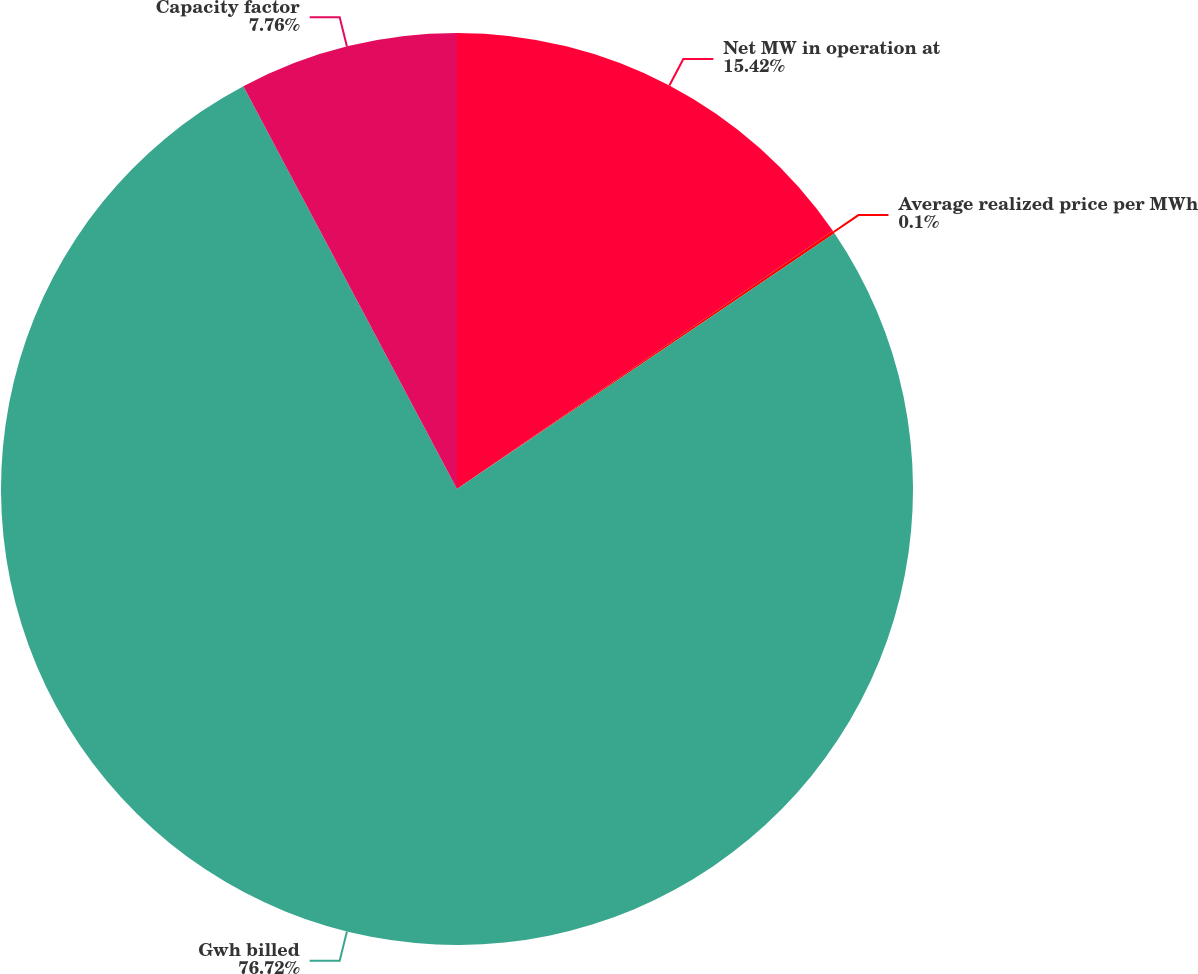Convert chart. <chart><loc_0><loc_0><loc_500><loc_500><pie_chart><fcel>Net MW in operation at<fcel>Average realized price per MWh<fcel>Gwh billed<fcel>Capacity factor<nl><fcel>15.42%<fcel>0.1%<fcel>76.72%<fcel>7.76%<nl></chart> 